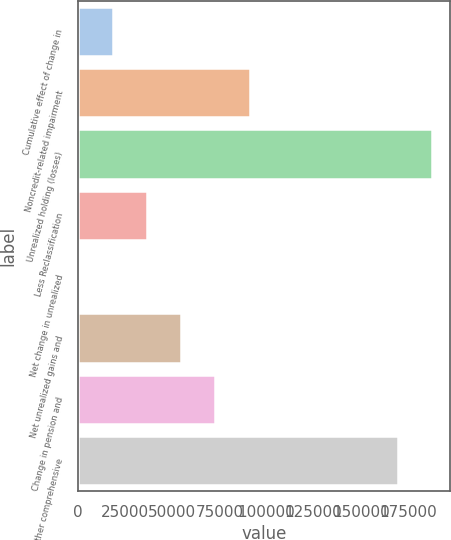Convert chart. <chart><loc_0><loc_0><loc_500><loc_500><bar_chart><fcel>Cumulative effect of change in<fcel>Noncredit-related impairment<fcel>Unrealized holding (losses)<fcel>Less Reclassification<fcel>Net change in unrealized<fcel>Net unrealized gains and<fcel>Change in pension and<fcel>Total other comprehensive<nl><fcel>18217.4<fcel>91059<fcel>187918<fcel>36427.8<fcel>7<fcel>54638.2<fcel>72848.6<fcel>169708<nl></chart> 